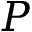Convert formula to latex. <formula><loc_0><loc_0><loc_500><loc_500>P</formula> 